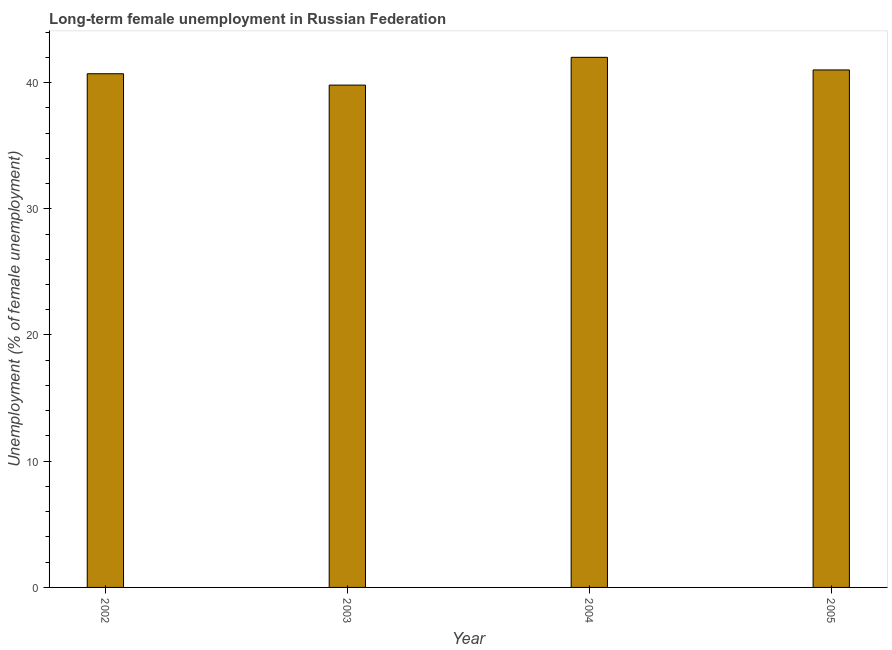What is the title of the graph?
Give a very brief answer. Long-term female unemployment in Russian Federation. What is the label or title of the X-axis?
Make the answer very short. Year. What is the label or title of the Y-axis?
Your answer should be compact. Unemployment (% of female unemployment). What is the long-term female unemployment in 2004?
Provide a short and direct response. 42. Across all years, what is the minimum long-term female unemployment?
Ensure brevity in your answer.  39.8. In which year was the long-term female unemployment minimum?
Give a very brief answer. 2003. What is the sum of the long-term female unemployment?
Ensure brevity in your answer.  163.5. What is the difference between the long-term female unemployment in 2003 and 2004?
Your answer should be very brief. -2.2. What is the average long-term female unemployment per year?
Give a very brief answer. 40.88. What is the median long-term female unemployment?
Provide a short and direct response. 40.85. In how many years, is the long-term female unemployment greater than 6 %?
Provide a succinct answer. 4. Do a majority of the years between 2004 and 2005 (inclusive) have long-term female unemployment greater than 40 %?
Offer a very short reply. Yes. What is the ratio of the long-term female unemployment in 2003 to that in 2004?
Keep it short and to the point. 0.95. Is the sum of the long-term female unemployment in 2002 and 2003 greater than the maximum long-term female unemployment across all years?
Provide a succinct answer. Yes. What is the difference between the highest and the lowest long-term female unemployment?
Provide a succinct answer. 2.2. In how many years, is the long-term female unemployment greater than the average long-term female unemployment taken over all years?
Offer a very short reply. 2. How many bars are there?
Your answer should be compact. 4. What is the Unemployment (% of female unemployment) in 2002?
Offer a terse response. 40.7. What is the Unemployment (% of female unemployment) of 2003?
Offer a very short reply. 39.8. What is the Unemployment (% of female unemployment) of 2004?
Provide a short and direct response. 42. What is the Unemployment (% of female unemployment) in 2005?
Keep it short and to the point. 41. What is the difference between the Unemployment (% of female unemployment) in 2002 and 2005?
Keep it short and to the point. -0.3. What is the difference between the Unemployment (% of female unemployment) in 2003 and 2004?
Offer a terse response. -2.2. What is the difference between the Unemployment (% of female unemployment) in 2003 and 2005?
Offer a terse response. -1.2. What is the difference between the Unemployment (% of female unemployment) in 2004 and 2005?
Offer a very short reply. 1. What is the ratio of the Unemployment (% of female unemployment) in 2002 to that in 2003?
Your answer should be compact. 1.02. What is the ratio of the Unemployment (% of female unemployment) in 2002 to that in 2004?
Keep it short and to the point. 0.97. What is the ratio of the Unemployment (% of female unemployment) in 2003 to that in 2004?
Your response must be concise. 0.95. 